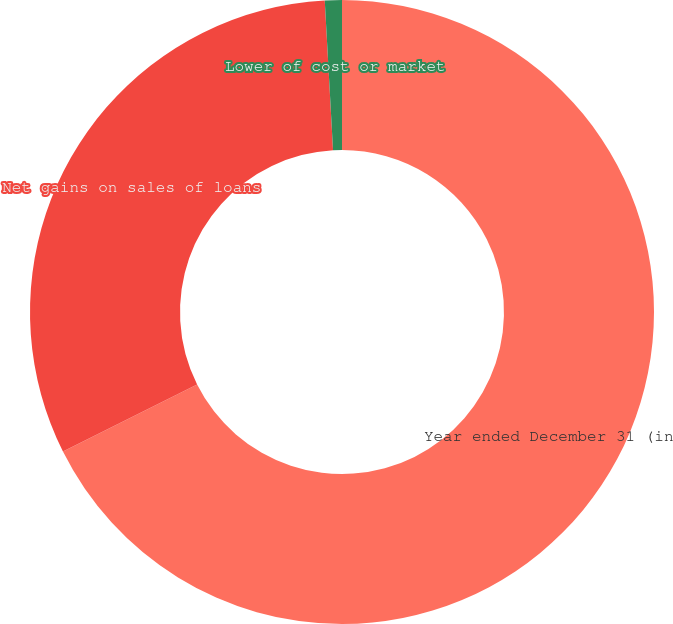<chart> <loc_0><loc_0><loc_500><loc_500><pie_chart><fcel>Year ended December 31 (in<fcel>Net gains on sales of loans<fcel>Lower of cost or market<nl><fcel>67.62%<fcel>31.5%<fcel>0.88%<nl></chart> 